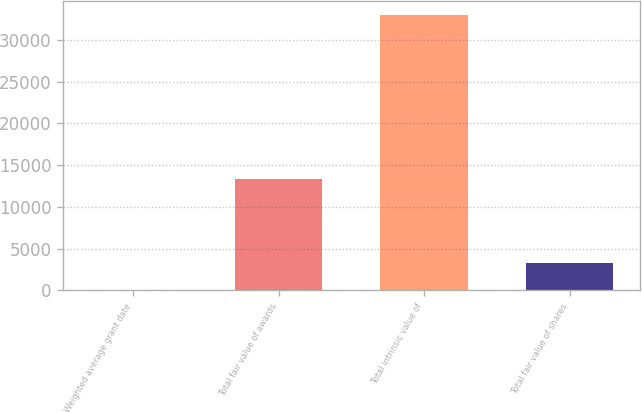<chart> <loc_0><loc_0><loc_500><loc_500><bar_chart><fcel>Weighted average grant date<fcel>Total fair value of awards<fcel>Total intrinsic value of<fcel>Total fair value of shares<nl><fcel>4.76<fcel>13388<fcel>32940<fcel>3298.28<nl></chart> 